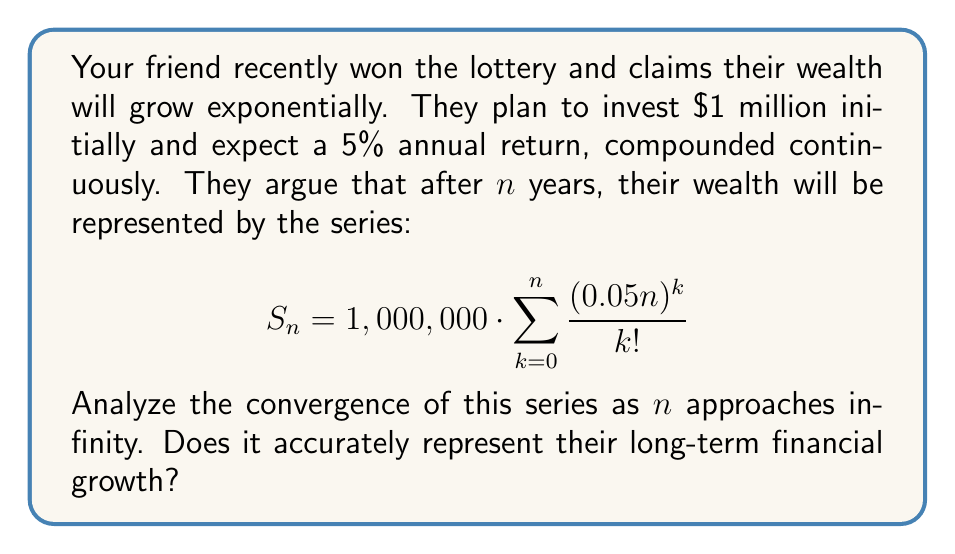Show me your answer to this math problem. Let's approach this step-by-step:

1) First, we need to recognize the series. The sum in the equation is actually the Taylor series expansion of $e^x$, where $x = 0.05n$:

   $$ e^x = \sum_{k=0}^{\infty} \frac{x^k}{k!} $$

2) Therefore, we can rewrite the series as:

   $$ S_n = 1,000,000 \cdot e^{0.05n} $$

3) As $n$ approaches infinity, this expression will also approach infinity, because $e^x$ grows without bound as $x$ increases.

4) To analyze the convergence, we need to consider the limit:

   $$ \lim_{n \to \infty} S_n = \lim_{n \to \infty} 1,000,000 \cdot e^{0.05n} = \infty $$

5) This limit diverges to infinity, which means the series does not converge to a finite value.

6) However, this divergence actually accurately represents exponential financial growth. In this case, it represents continuous compound interest at a 5% annual rate.

7) The formula $A = P \cdot e^{rt}$ is the standard formula for continuous compound interest, where:
   - A is the final amount
   - P is the principal (initial investment)
   - r is the annual interest rate (as a decimal)
   - t is the time in years

8) In this case, $P = 1,000,000$, $r = 0.05$, and $t = n$, which matches our derived formula exactly.

Therefore, while the series doesn't converge to a finite value, it does accurately represent the friend's long-term financial growth under the assumed conditions.
Answer: The series diverges but accurately represents exponential financial growth with continuous compound interest. 